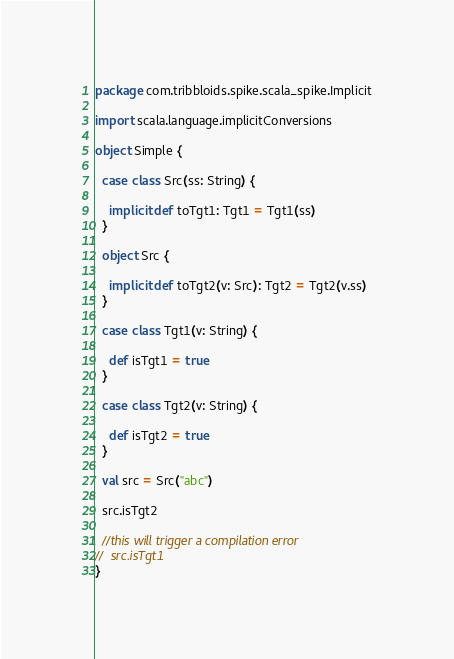Convert code to text. <code><loc_0><loc_0><loc_500><loc_500><_Scala_>package com.tribbloids.spike.scala_spike.Implicit

import scala.language.implicitConversions

object Simple {

  case class Src(ss: String) {

    implicit def toTgt1: Tgt1 = Tgt1(ss)
  }

  object Src {

    implicit def toTgt2(v: Src): Tgt2 = Tgt2(v.ss)
  }

  case class Tgt1(v: String) {

    def isTgt1 = true
  }

  case class Tgt2(v: String) {

    def isTgt2 = true
  }

  val src = Src("abc")

  src.isTgt2

  //this will trigger a compilation error
//  src.isTgt1
}
</code> 